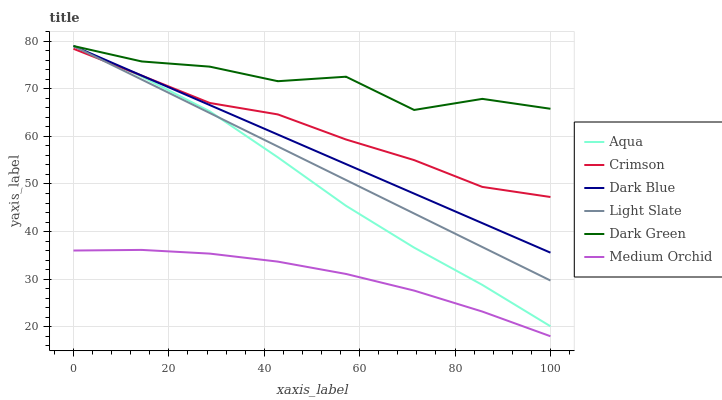Does Medium Orchid have the minimum area under the curve?
Answer yes or no. Yes. Does Dark Green have the maximum area under the curve?
Answer yes or no. Yes. Does Aqua have the minimum area under the curve?
Answer yes or no. No. Does Aqua have the maximum area under the curve?
Answer yes or no. No. Is Light Slate the smoothest?
Answer yes or no. Yes. Is Dark Green the roughest?
Answer yes or no. Yes. Is Medium Orchid the smoothest?
Answer yes or no. No. Is Medium Orchid the roughest?
Answer yes or no. No. Does Medium Orchid have the lowest value?
Answer yes or no. Yes. Does Aqua have the lowest value?
Answer yes or no. No. Does Dark Green have the highest value?
Answer yes or no. Yes. Does Medium Orchid have the highest value?
Answer yes or no. No. Is Medium Orchid less than Crimson?
Answer yes or no. Yes. Is Dark Blue greater than Medium Orchid?
Answer yes or no. Yes. Does Crimson intersect Light Slate?
Answer yes or no. Yes. Is Crimson less than Light Slate?
Answer yes or no. No. Is Crimson greater than Light Slate?
Answer yes or no. No. Does Medium Orchid intersect Crimson?
Answer yes or no. No. 